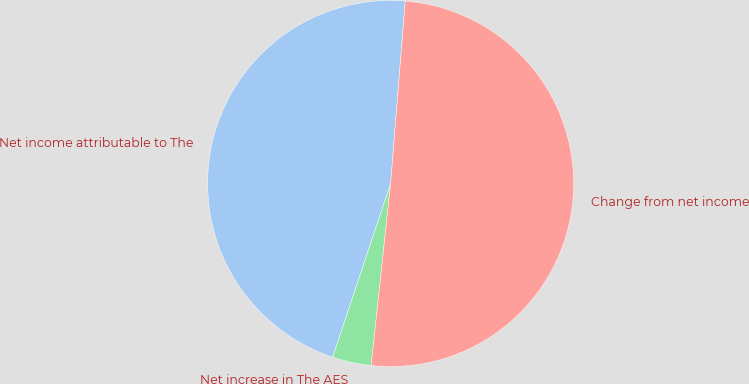<chart> <loc_0><loc_0><loc_500><loc_500><pie_chart><fcel>Net income attributable to The<fcel>Net increase in The AES<fcel>Change from net income<nl><fcel>46.15%<fcel>3.43%<fcel>50.42%<nl></chart> 